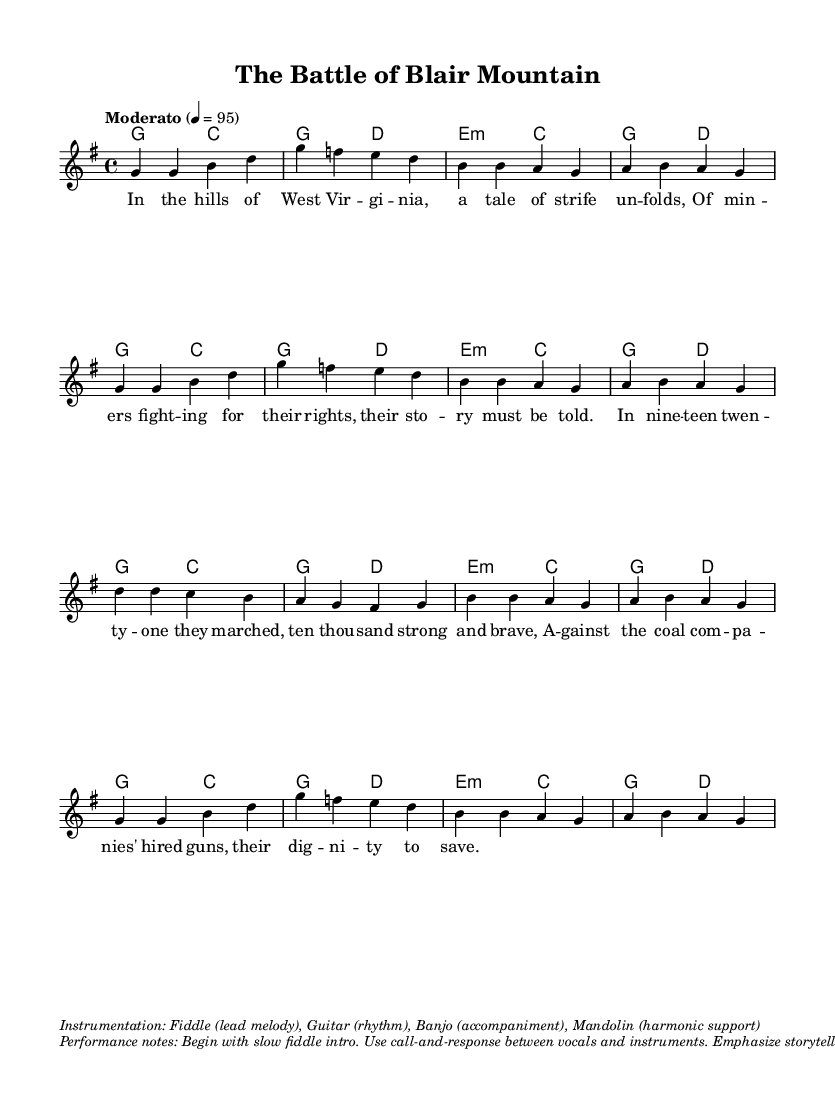What is the key signature of this music? The key signature is G major, which has one sharp (F#). This is indicated in the global section of the LilyPond code where the key is set as \key g \major.
Answer: G major What is the time signature of this music? The time signature is 4/4, meaning there are four beats in each measure. This is established in the global section with the \time 4/4 directive.
Answer: 4/4 What is the tempo marking for this piece? The tempo marking is Moderato, which indicates a moderate pace. This is specified in the global section as \tempo "Moderato" 4 = 95.
Answer: Moderato Which instruments are specified in the performance notes? The performance notes mention four instruments: Fiddle, Guitar, Banjo, and Mandolin. This information is provided in the markup section under instrumentation, indicating the roles each instrument plays in the arrangement.
Answer: Fiddle, Guitar, Banjo, Mandolin How many verses are there in the lyrics provided? The lyrics only display one verse, as indicated by the lyricmode section of the code where a single verse is set. There is no additional verse indicated in the provided material.
Answer: One What historical event is referenced in the lyrics? The lyrics reference the Battle of Blair Mountain, which depicts miners fighting for their rights against coal companies. This title is provided in the header of the score.
Answer: Battle of Blair Mountain 